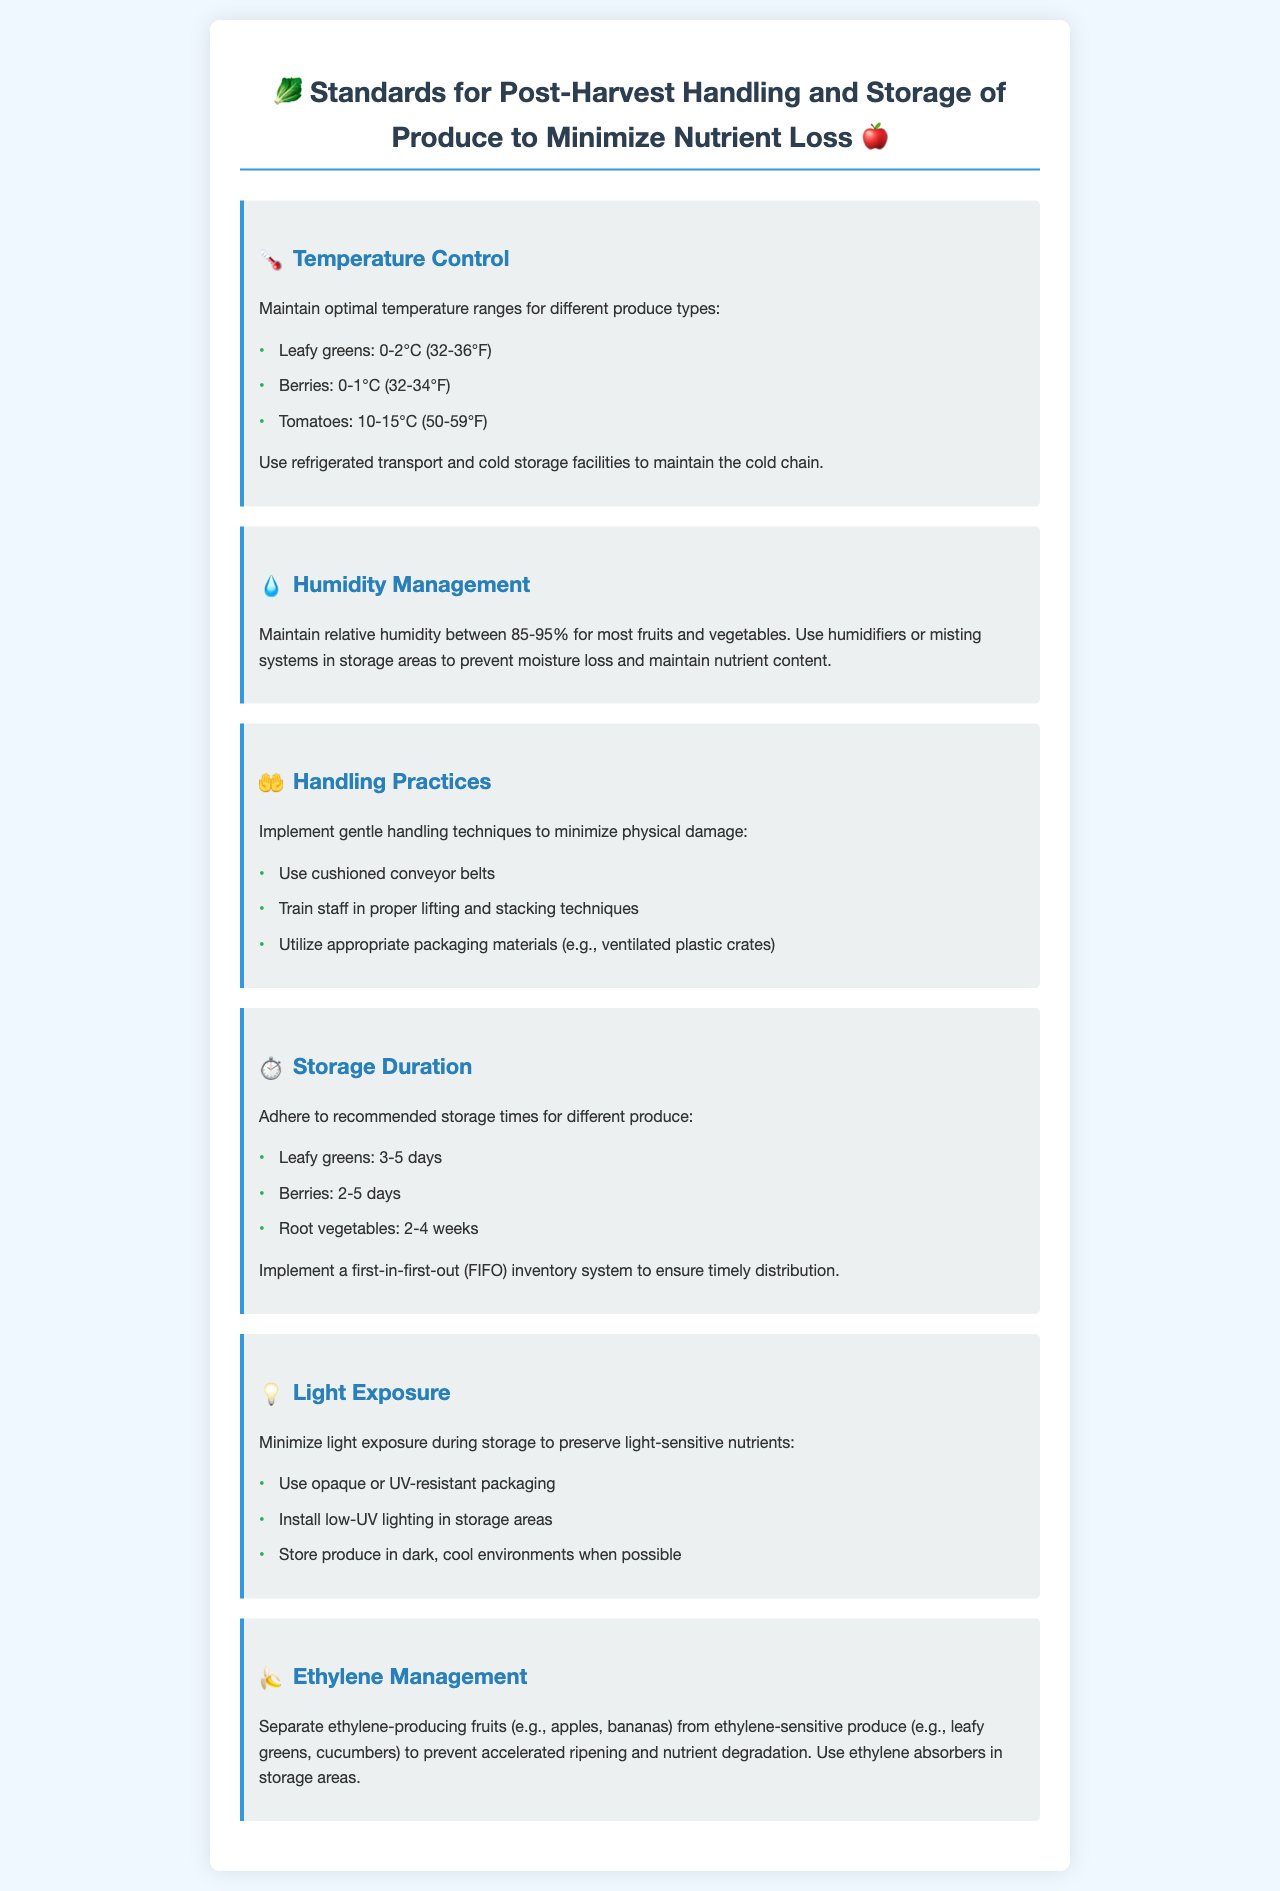What is the optimal temperature range for leafy greens? The document lists the optimal temperature range for leafy greens as 0-2°C (32-36°F).
Answer: 0-2°C (32-36°F) What is the recommended relative humidity for most fruits and vegetables? The document states that the recommended relative humidity for most fruits and vegetables is between 85-95%.
Answer: 85-95% How many days should leafy greens be stored? The document indicates that leafy greens should be stored for 3-5 days.
Answer: 3-5 days What type of packaging should be used to minimize light exposure? It mentions using opaque or UV-resistant packaging to minimize light exposure.
Answer: Opaque or UV-resistant packaging Which fruits should be separated from ethylene-sensitive produce? The document specifies ethylene-producing fruits like apples and bananas should be separated from ethylene-sensitive produce.
Answer: Apples, bananas Explain why ethylene management is important. Ethylene management is important to prevent accelerated ripening and nutrient degradation in sensitive produce.
Answer: Prevent accelerated ripening and nutrient degradation What handling technique is recommended for minimizing physical damage? The document recommends using cushioned conveyor belts as a handling technique.
Answer: Cushioned conveyor belts What storage inventory system should be implemented? The document states that a first-in-first-out (FIFO) inventory system should be implemented.
Answer: First-in-first-out (FIFO) 